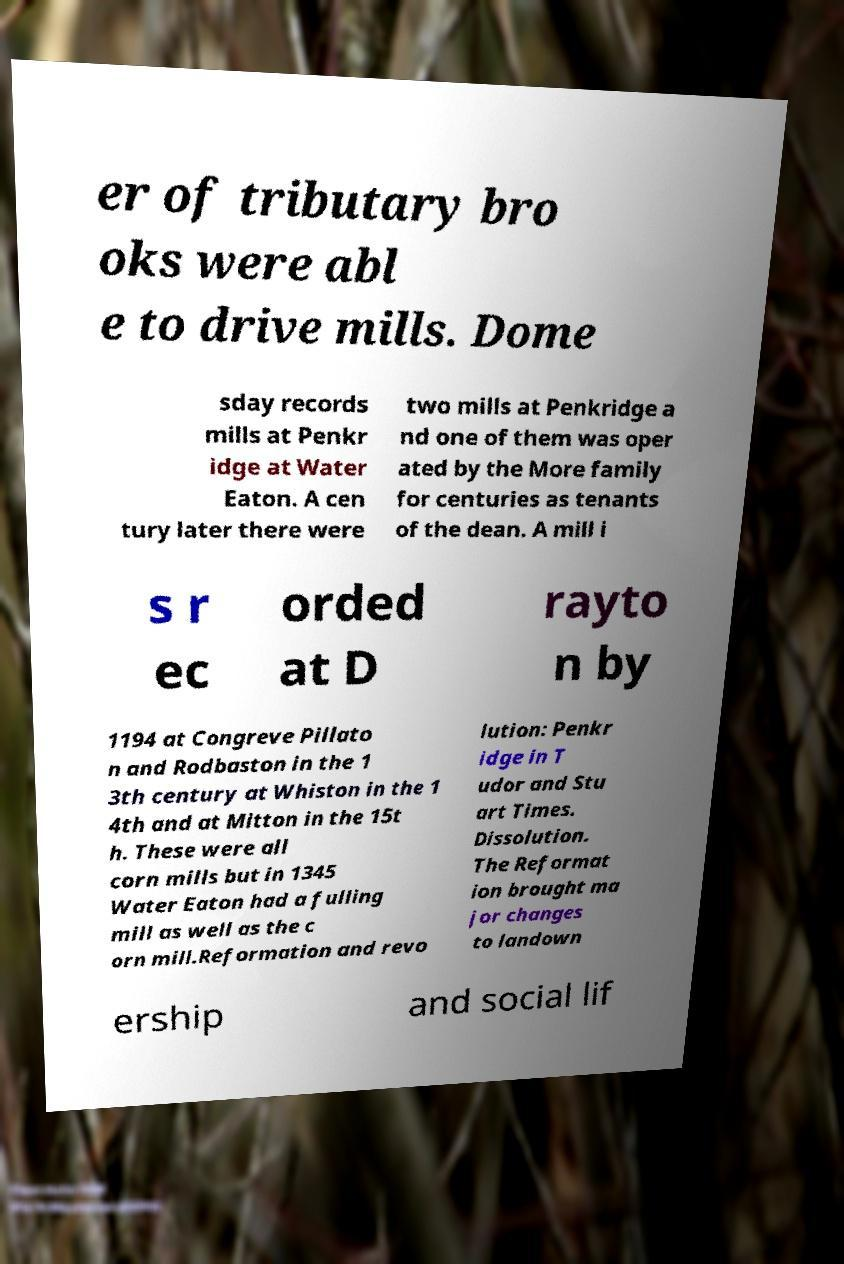Please read and relay the text visible in this image. What does it say? er of tributary bro oks were abl e to drive mills. Dome sday records mills at Penkr idge at Water Eaton. A cen tury later there were two mills at Penkridge a nd one of them was oper ated by the More family for centuries as tenants of the dean. A mill i s r ec orded at D rayto n by 1194 at Congreve Pillato n and Rodbaston in the 1 3th century at Whiston in the 1 4th and at Mitton in the 15t h. These were all corn mills but in 1345 Water Eaton had a fulling mill as well as the c orn mill.Reformation and revo lution: Penkr idge in T udor and Stu art Times. Dissolution. The Reformat ion brought ma jor changes to landown ership and social lif 